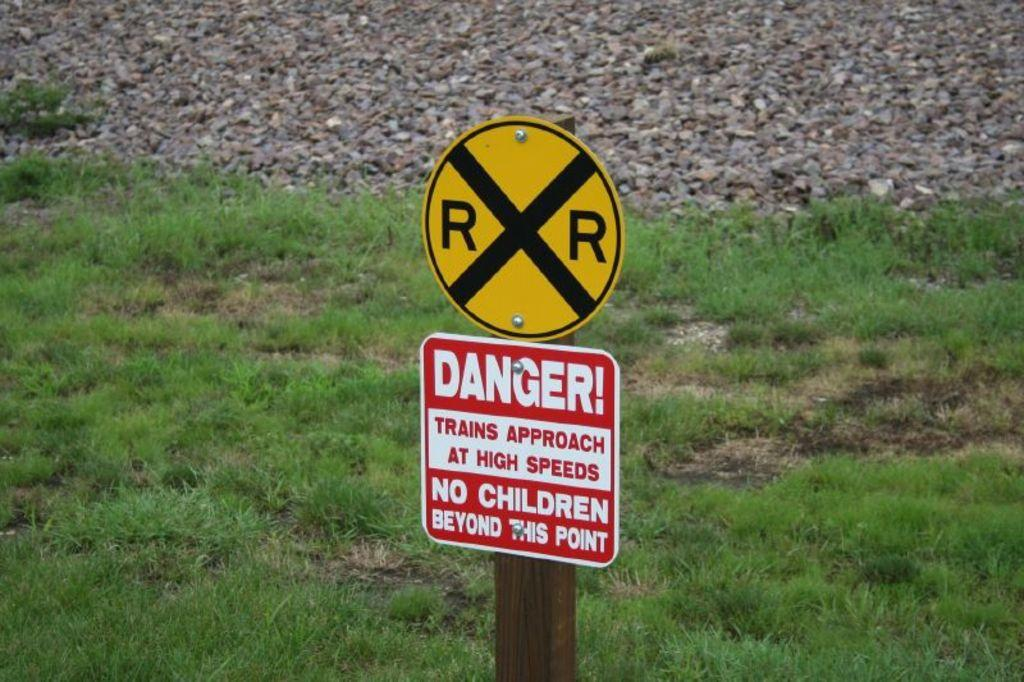<image>
Write a terse but informative summary of the picture. A railroad crossing sign with a danger sign underneath it. 